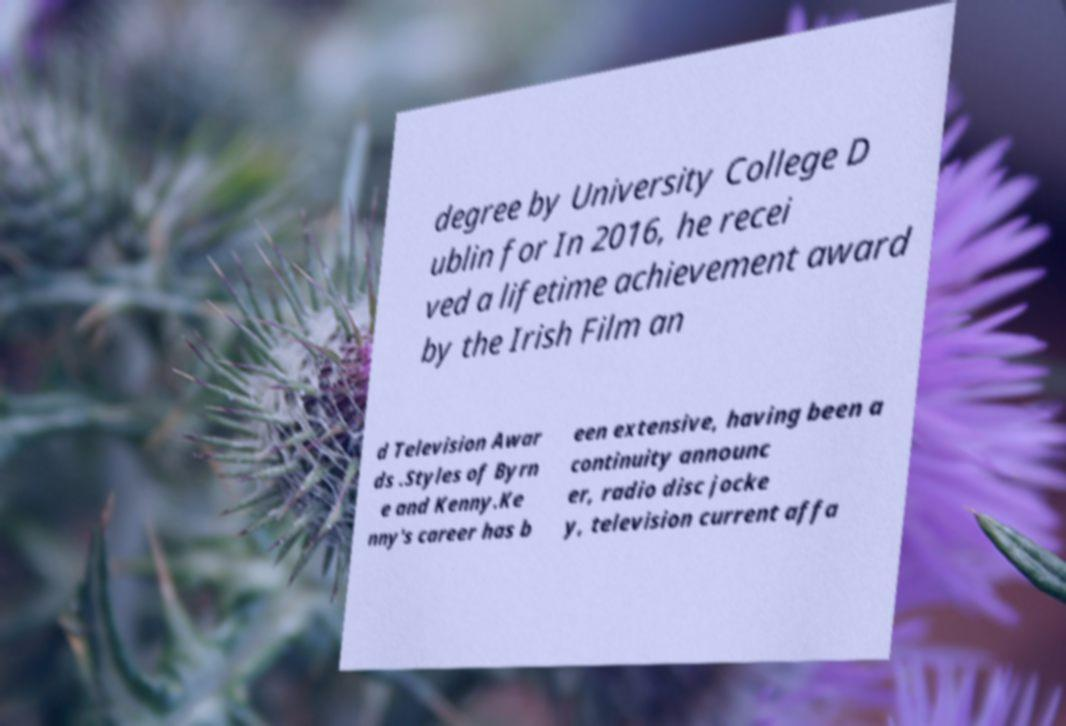Could you assist in decoding the text presented in this image and type it out clearly? degree by University College D ublin for In 2016, he recei ved a lifetime achievement award by the Irish Film an d Television Awar ds .Styles of Byrn e and Kenny.Ke nny's career has b een extensive, having been a continuity announc er, radio disc jocke y, television current affa 